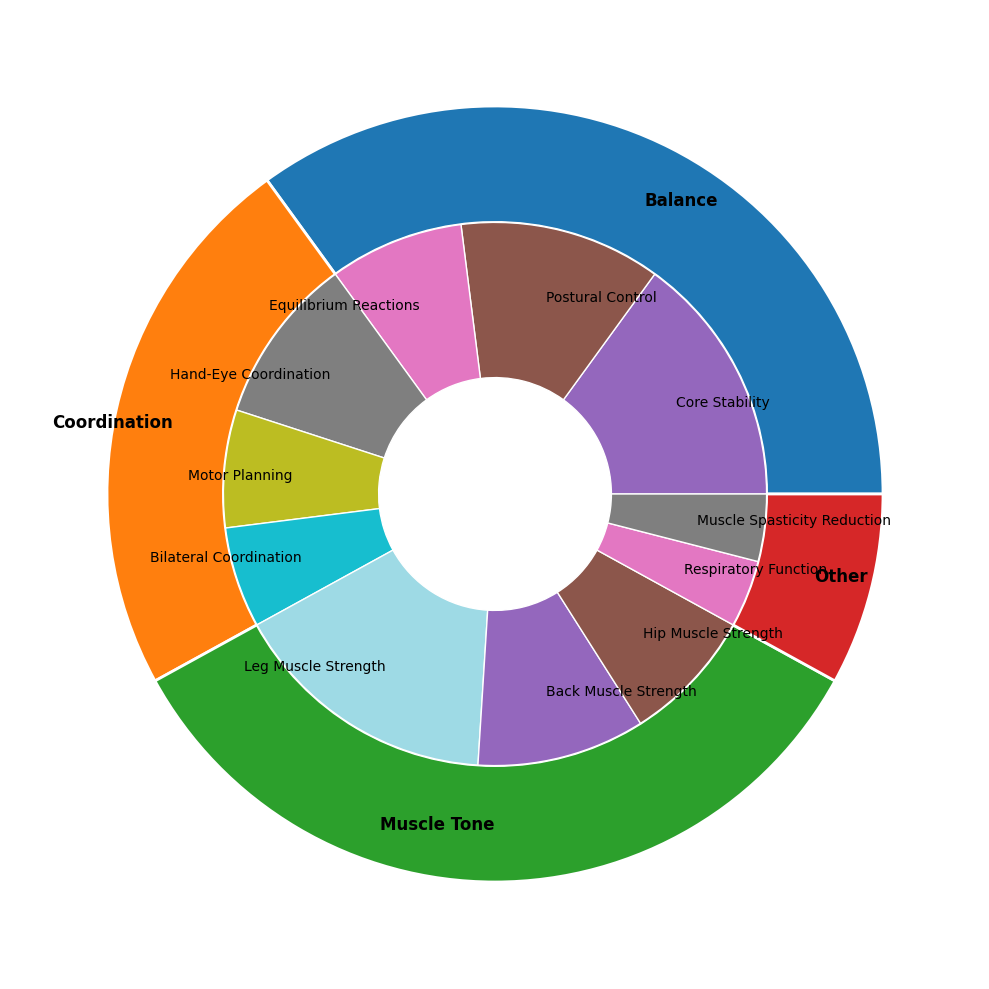Which Improvement Area has the highest overall percentage? By looking at the outer pie chart, observe which segment is the largest. The "Muscle Tone" segment is the largest, indicating it has the highest overall percentage.
Answer: Muscle Tone What is the combined percentage of Core Stability and Postural Control subcategories within the Balance Improvement Area? Add the percentage values of Core Stability (15%) and Postural Control (12%) together: 15% + 12% = 27%
Answer: 27% How does the percentage of Leg Muscle Strength compare to Hand-Eye Coordination? Compare the sizes of the wedges representing Leg Muscle Strength (16%) and Hand-Eye Coordination (10%) by visually inspecting the inner pie chart. Leg Muscle Strength has a larger percentage.
Answer: Leg Muscle Strength is greater Which subcategory under Coordination has the smallest percentage? Identify the smallest wedge segment within the Coordination Improvement Area in the inner pie chart. Bilateral Coordination (6%) is the smallest subcategory under Coordination.
Answer: Bilateral Coordination What is the total percentage for Improvement Areas excluding Other? Sum the overall percentages of Balance (35%), Coordination (23%), and Muscle Tone (34%), and exclude Other: 35% + 23% + 34% = 92%
Answer: 92% Which subcategory within the Muscle Tone Improvement Area has the highest percentage? Examine the inner pie chart and identify the largest segment within the Muscle Tone Improvement Area. Leg Muscle Strength (16%) is the largest subcategory.
Answer: Leg Muscle Strength What is the difference in percentage between Back Muscle Strength and Hip Muscle Strength? Subtract the percentage of Hip Muscle Strength (8%) from Back Muscle Strength (10%): 10% - 8% = 2%
Answer: 2% How many subcategories are there under the Balance Improvement Area? Count the number of distinct wedges within the Balance segment of the inner pie chart. There are three subcategories: Core Stability, Postural Control, and Equilibrium Reactions.
Answer: 3 What percentage of the overall chart is attributed to Muscle Spasticity Reduction? Find the wedge corresponding to Muscle Spasticity Reduction in the inner pie chart and note its percentage (4%). This is the percentage of the overall chart attributed to Muscle Spasticity Reduction.
Answer: 4% What is the visual difference between the Balance and Other segments in terms of overall size? Compare the outer pie chart segments of Balance and Other. The Balance segment visually appears much larger than the Other segment, indicating a significant size difference.
Answer: Balance is much larger 